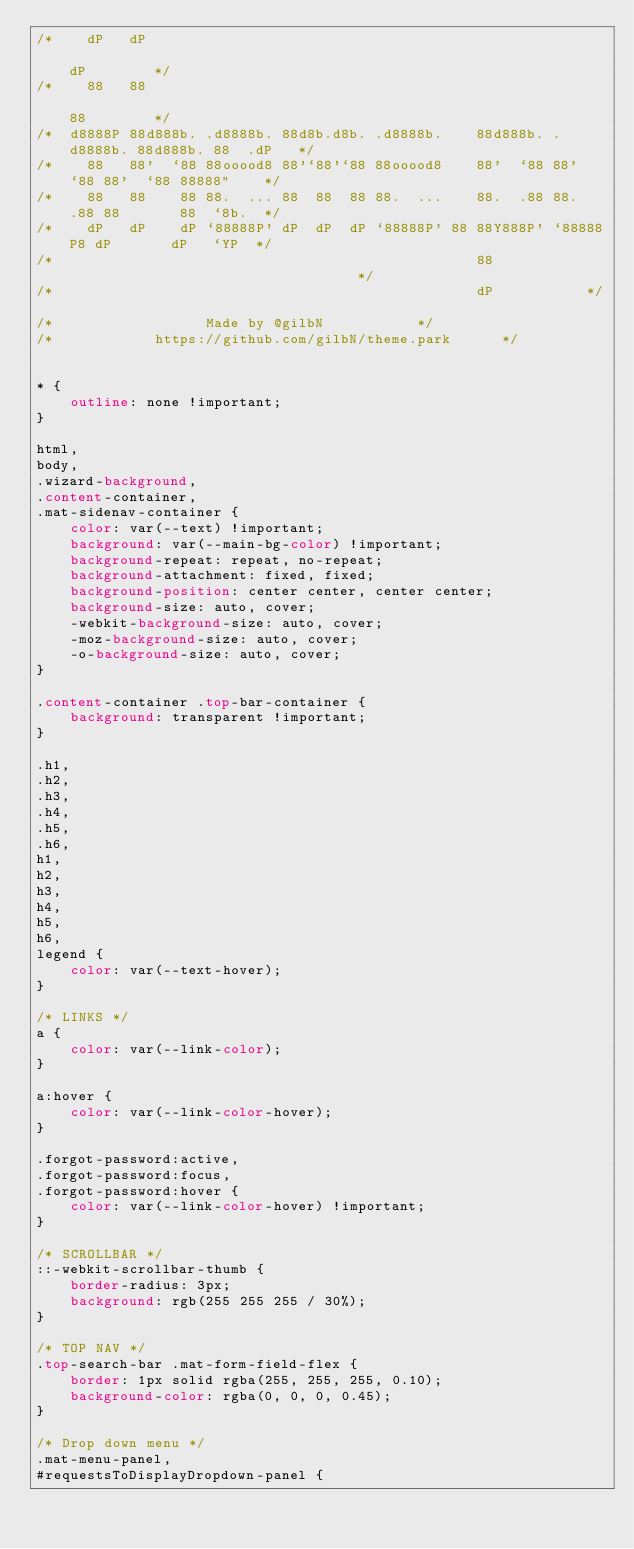Convert code to text. <code><loc_0><loc_0><loc_500><loc_500><_CSS_>/*    dP   dP                                                                  dP        */
/*    88   88                                                                  88        */
/*  d8888P 88d888b. .d8888b. 88d8b.d8b. .d8888b.    88d888b. .d8888b. 88d888b. 88  .dP   */
/*    88   88'  `88 88ooood8 88'`88'`88 88ooood8    88'  `88 88'  `88 88'  `88 88888"    */
/*    88   88    88 88.  ... 88  88  88 88.  ...    88.  .88 88.  .88 88       88  `8b.  */
/*    dP   dP    dP `88888P' dP  dP  dP `88888P' 88 88Y888P' `88888P8 dP       dP   `YP  */
/*                                                  88                                   */
/*                                                  dP					 */

/*		   		        Made by @gilbN					 */
/*			      https://github.com/gilbN/theme.park			 */


* {
    outline: none !important;
}

html,
body,
.wizard-background,
.content-container,
.mat-sidenav-container {
    color: var(--text) !important;
    background: var(--main-bg-color) !important;
    background-repeat: repeat, no-repeat;
    background-attachment: fixed, fixed;
    background-position: center center, center center;
    background-size: auto, cover;
    -webkit-background-size: auto, cover;
    -moz-background-size: auto, cover;
    -o-background-size: auto, cover;
}

.content-container .top-bar-container {
    background: transparent !important;
}

.h1,
.h2,
.h3,
.h4,
.h5,
.h6,
h1,
h2,
h3,
h4,
h5,
h6,
legend {
    color: var(--text-hover);
}

/* LINKS */
a {
    color: var(--link-color);
}

a:hover {
    color: var(--link-color-hover);
}

.forgot-password:active,
.forgot-password:focus,
.forgot-password:hover {
    color: var(--link-color-hover) !important;
}

/* SCROLLBAR */
::-webkit-scrollbar-thumb {
    border-radius: 3px;
    background: rgb(255 255 255 / 30%);
}

/* TOP NAV */
.top-search-bar .mat-form-field-flex {
    border: 1px solid rgba(255, 255, 255, 0.10);
    background-color: rgba(0, 0, 0, 0.45);
}

/* Drop down menu */
.mat-menu-panel,
#requestsToDisplayDropdown-panel {</code> 